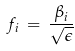Convert formula to latex. <formula><loc_0><loc_0><loc_500><loc_500>f _ { i } \, = \, \frac { \beta _ { i } } { \sqrt { \epsilon } }</formula> 